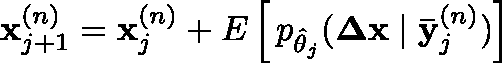Convert formula to latex. <formula><loc_0><loc_0><loc_500><loc_500>x _ { j + 1 } ^ { ( n ) } = x _ { j } ^ { ( n ) } + \mathbb { E } \left [ \, p _ { \hat { \theta } _ { j } } ( \Delta x | \bar { y } _ { j } ^ { ( n ) } ) \right ]</formula> 